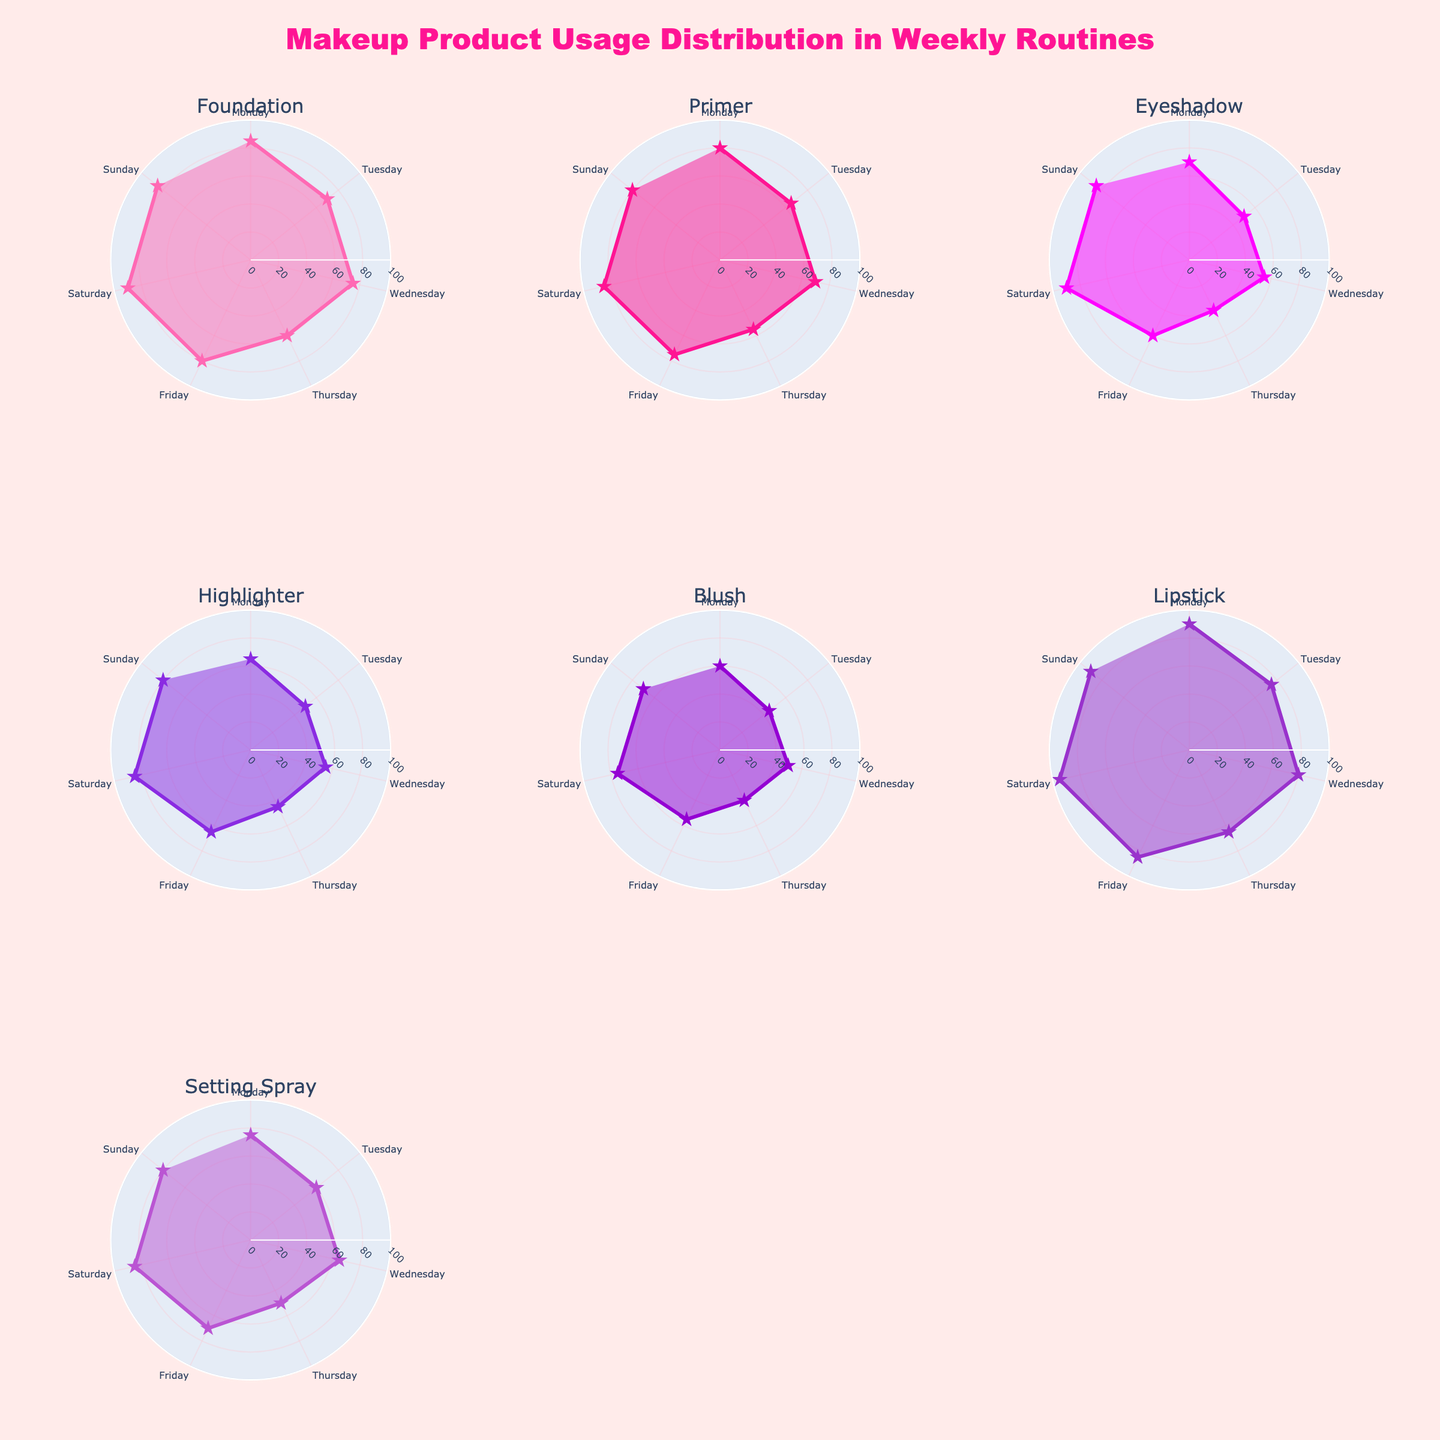Which product has the highest average usage frequency? To find the product with the highest average usage frequency, calculate the average usage frequency for each product across all days and compare them. The averages are as follows: Foundation (78), Primer (73), Eyeshadow (64.29), Highlighter (63.57), Blush (56.43), Lipstick (82.86), Setting Spray (69.29). Lipstick has the highest average usage frequency.
Answer: Lipstick Which day of the week has the highest overall usage frequency across all products? First, sum the usage frequencies of all products for each day. The totals are: Monday (525), Tuesday (415), Wednesday (450), Thursday (355), Friday (490), Saturday (605), Sunday (570). Saturday has the highest overall usage frequency.
Answer: Saturday How does the usage of Highlighter on Tuesday compare to the usage of Eyeshadow on Thursday? Locate the usage frequencies for Highlighter on Tuesday (50) and Eyeshadow on Thursday (40) and compare them. Highlighter usage on Tuesday is higher than Eyeshadow usage on Thursday.
Answer: Higher What is the overall trend of Lipstick usage throughout the week? Observe the plot for Lipstick and note the usage frequencies: Monday (90), Tuesday (75), Wednesday (80), Thursday (65), Friday (85), Saturday (95), Sunday (90). Lipstick usage starts high on Monday, dips midweek, and peaks on Saturday, before slightly dropping but staying high on Sunday.
Answer: High, dip, peak, high How does the average weekend (Saturday and Sunday) foundation usage compare to the average weekday (Monday to Friday) usage? Calculate the average for Saturday and Sunday combined (87.5) and Monday to Friday combined (74). Perform the comparison: (87.5 is higher than 74). Therefore, weekend foundation usage is higher.
Answer: Higher Which product shows the widest range in usage frequency over the week? Calculate the range for each product: Foundation (90-60=30), Primer (85-55=30), Eyeshadow (90-40=50), Highlighter (85-45=40), Blush (75-40=35), Lipstick (95-65=30), Setting Spray (85-50=35). Eyeshadow shows the widest range of usage frequency.
Answer: Eyeshadow On which day is Setting Spray used the least? Identify the usage frequencies of Setting Spray for each day and find the minimum: Monday (75), Tuesday (60), Wednesday (65), Thursday (50), Friday (70), Saturday (85), Sunday (80). Thursday has the least usage.
Answer: Thursday How does the usage pattern of Blush compare with that of Setting Spray over the week? Analyze and compare the trends of Blush and Setting Spray: Blush - Monday (60), Tuesday (45), Wednesday (50), Thursday (40), Friday (55), Saturday (75), Sunday (70). Setting Spray - Monday (75), Tuesday (60), Wednesday (65), Thursday (50), Friday (70), Saturday (85), Sunday (80). Both products generally increase from the middle of the week towards the weekend, with Setting Spray having a higher usage overall.
Answer: Similar trend but Setting Spray higher Which two products have the closest average usage frequencies? Calculate the average usage frequency for each product: Foundation (78), Primer (73), Eyeshadow (64.29), Highlighter (63.57), Blush (56.43), Lipstick (82.86), Setting Spray (69.29). Highlighter and Eyeshadow have the closest averages.
Answer: Highlighter and Eyeshadow 